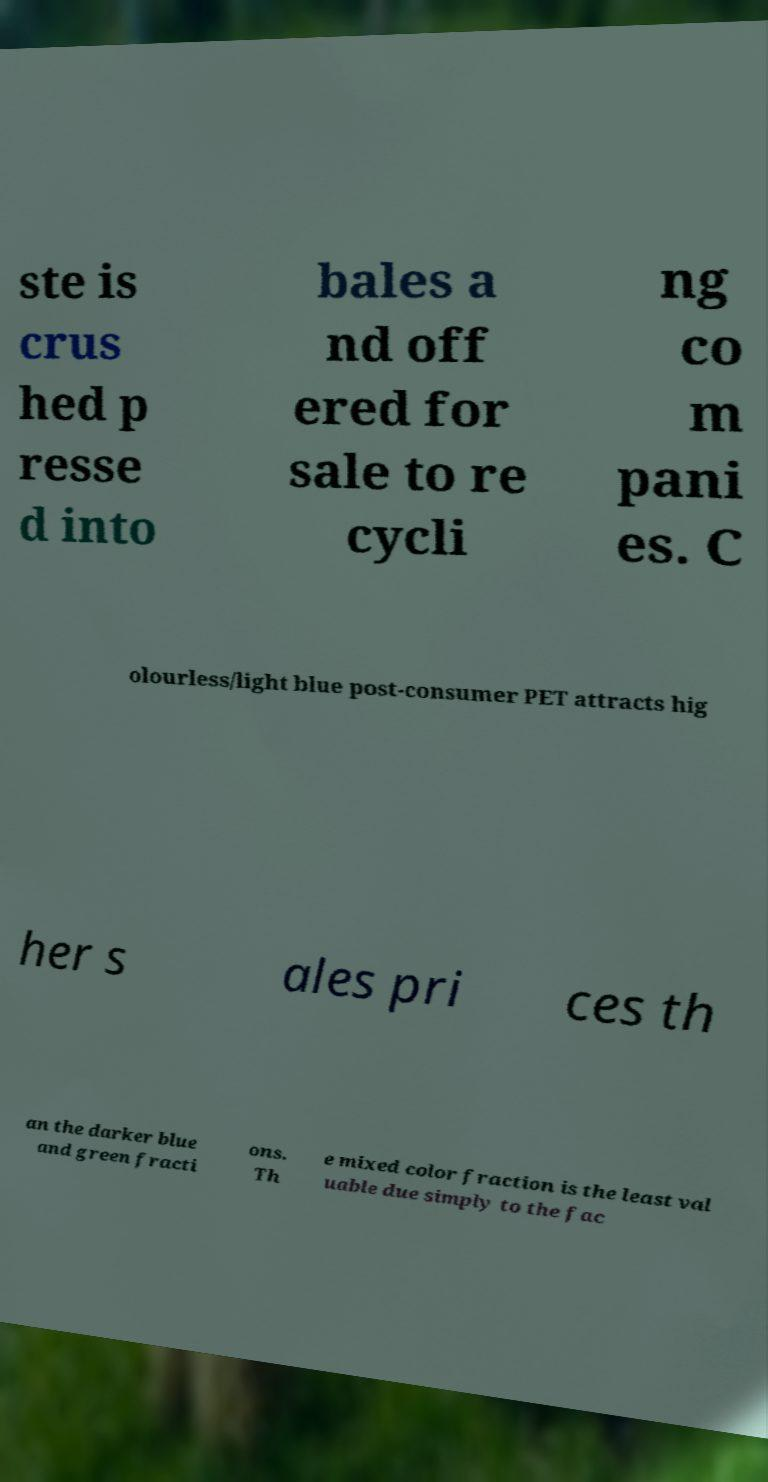Can you read and provide the text displayed in the image?This photo seems to have some interesting text. Can you extract and type it out for me? ste is crus hed p resse d into bales a nd off ered for sale to re cycli ng co m pani es. C olourless/light blue post-consumer PET attracts hig her s ales pri ces th an the darker blue and green fracti ons. Th e mixed color fraction is the least val uable due simply to the fac 